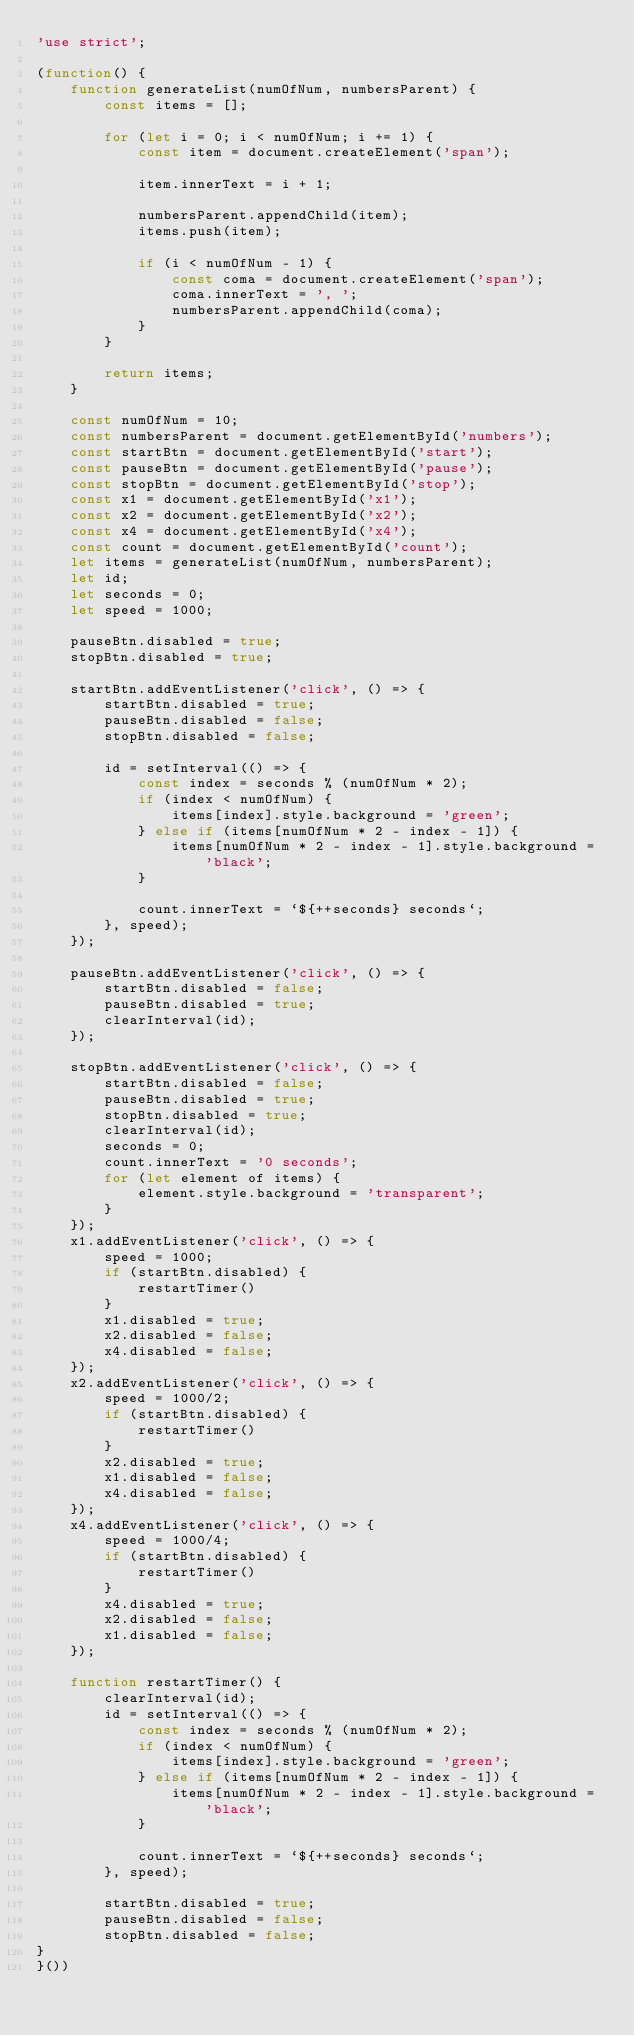<code> <loc_0><loc_0><loc_500><loc_500><_JavaScript_>'use strict';

(function() {
    function generateList(numOfNum, numbersParent) {
        const items = [];

        for (let i = 0; i < numOfNum; i += 1) {
            const item = document.createElement('span');

            item.innerText = i + 1;

            numbersParent.appendChild(item);
            items.push(item);

            if (i < numOfNum - 1) {
                const coma = document.createElement('span');
                coma.innerText = ', ';
                numbersParent.appendChild(coma);
            }
        }

        return items;
    }

    const numOfNum = 10;
    const numbersParent = document.getElementById('numbers');
    const startBtn = document.getElementById('start');
    const pauseBtn = document.getElementById('pause');
    const stopBtn = document.getElementById('stop');
    const x1 = document.getElementById('x1');
    const x2 = document.getElementById('x2');
    const x4 = document.getElementById('x4');
    const count = document.getElementById('count');
    let items = generateList(numOfNum, numbersParent);
    let id;
    let seconds = 0;
    let speed = 1000;

    pauseBtn.disabled = true;
    stopBtn.disabled = true;

    startBtn.addEventListener('click', () => {
        startBtn.disabled = true;
        pauseBtn.disabled = false;
        stopBtn.disabled = false;

        id = setInterval(() => {
            const index = seconds % (numOfNum * 2);
            if (index < numOfNum) {
                items[index].style.background = 'green';
            } else if (items[numOfNum * 2 - index - 1]) {
                items[numOfNum * 2 - index - 1].style.background = 'black';
            }

            count.innerText = `${++seconds} seconds`;
        }, speed);
    });

    pauseBtn.addEventListener('click', () => {
        startBtn.disabled = false;
        pauseBtn.disabled = true;
        clearInterval(id);
    });

    stopBtn.addEventListener('click', () => {
        startBtn.disabled = false;
        pauseBtn.disabled = true;
        stopBtn.disabled = true;
        clearInterval(id);
        seconds = 0;
        count.innerText = '0 seconds';
        for (let element of items) {
            element.style.background = 'transparent';
        }
    });
    x1.addEventListener('click', () => {
        speed = 1000;
        if (startBtn.disabled) {
            restartTimer()
        }
        x1.disabled = true;
        x2.disabled = false;
        x4.disabled = false;
    });
    x2.addEventListener('click', () => {
        speed = 1000/2;
        if (startBtn.disabled) {
            restartTimer()
        }
        x2.disabled = true;
        x1.disabled = false;
        x4.disabled = false;     
    });
    x4.addEventListener('click', () => {
        speed = 1000/4;
        if (startBtn.disabled) {
            restartTimer()
        }
        x4.disabled = true;
        x2.disabled = false;
        x1.disabled = false;
    });

    function restartTimer() {
        clearInterval(id);
        id = setInterval(() => {
            const index = seconds % (numOfNum * 2);
            if (index < numOfNum) {
                items[index].style.background = 'green';
            } else if (items[numOfNum * 2 - index - 1]) {
                items[numOfNum * 2 - index - 1].style.background = 'black';
            }

            count.innerText = `${++seconds} seconds`;
        }, speed);

        startBtn.disabled = true;
        pauseBtn.disabled = false;
        stopBtn.disabled = false;
}
}())</code> 